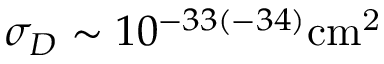<formula> <loc_0><loc_0><loc_500><loc_500>\sigma _ { D } \sim 1 0 ^ { - 3 3 ( - 3 4 ) } { c m } ^ { 2 }</formula> 